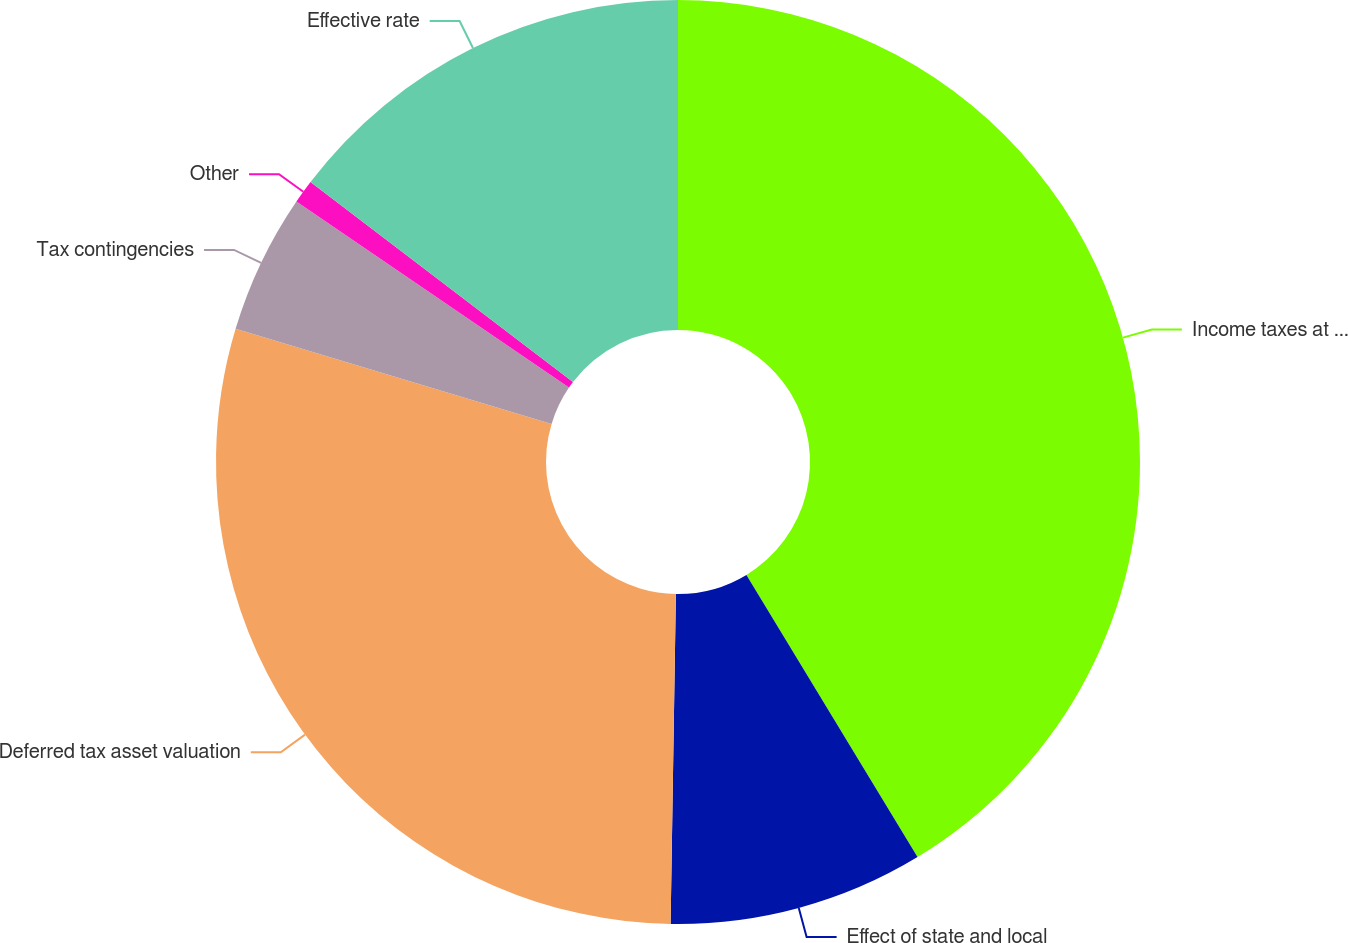Convert chart to OTSL. <chart><loc_0><loc_0><loc_500><loc_500><pie_chart><fcel>Income taxes at federal<fcel>Effect of state and local<fcel>Deferred tax asset valuation<fcel>Tax contingencies<fcel>Other<fcel>Effective rate<nl><fcel>41.33%<fcel>8.93%<fcel>29.4%<fcel>4.88%<fcel>0.83%<fcel>14.64%<nl></chart> 